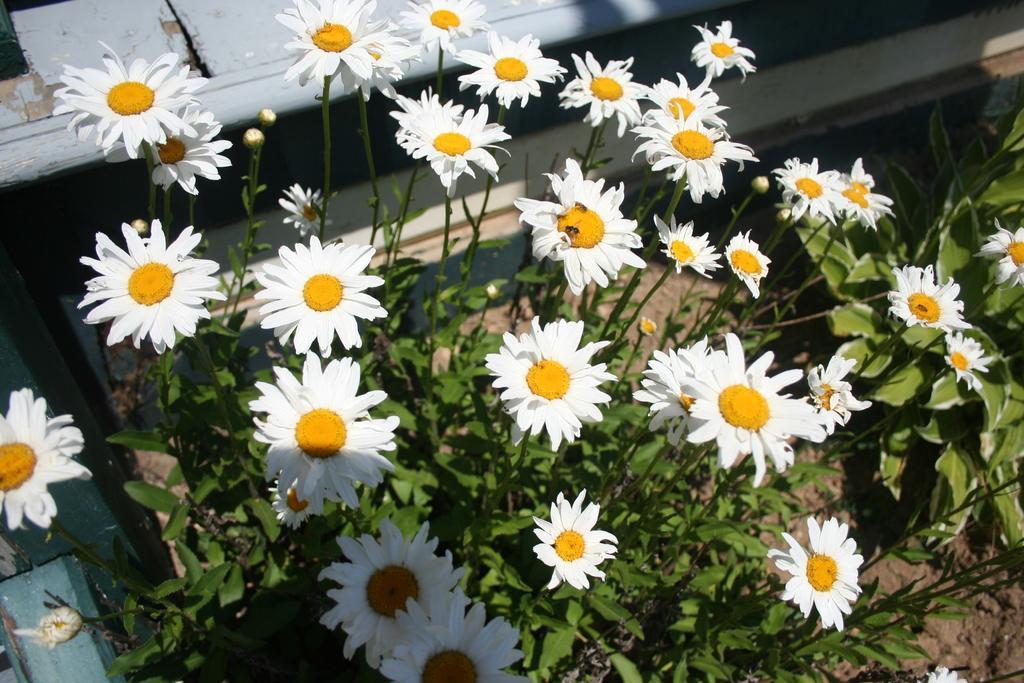Can you describe this image briefly? In this picture I can see flowers and plants. 